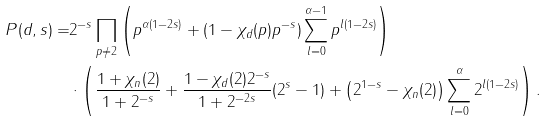Convert formula to latex. <formula><loc_0><loc_0><loc_500><loc_500>P ( d , s ) = & 2 ^ { - s } \prod _ { p \neq 2 } \left ( p ^ { \alpha ( 1 - 2 s ) } + ( 1 - \chi _ { d } ( p ) p ^ { - s } ) \sum ^ { \alpha - 1 } _ { l = 0 } p ^ { l ( 1 - 2 s ) } \right ) \\ & \cdot \left ( \frac { 1 + \chi _ { n } ( 2 ) } { 1 + 2 ^ { - s } } + \frac { 1 - \chi _ { d } ( 2 ) 2 ^ { - s } } { 1 + 2 ^ { - 2 s } } ( 2 ^ { s } - 1 ) + \left ( 2 ^ { 1 - s } - \chi _ { n } ( 2 ) \right ) \sum ^ { \alpha } _ { l = 0 } 2 ^ { l ( 1 - 2 s ) } \right ) .</formula> 